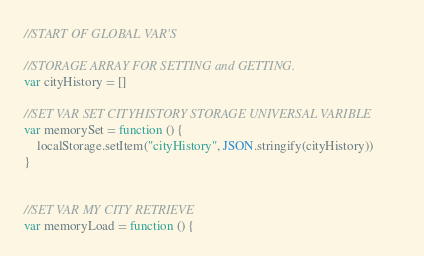<code> <loc_0><loc_0><loc_500><loc_500><_JavaScript_>
//START OF GLOBAL VAR'S

//STORAGE ARRAY FOR SETTING and GETTING. 
var cityHistory = []

//SET VAR SET CITYHISTORY STORAGE UNIVERSAL VARIBLE 
var memorySet = function () {
    localStorage.setItem("cityHistory", JSON.stringify(cityHistory))
}


//SET VAR MY CITY RETRIEVE
var memoryLoad = function () {</code> 